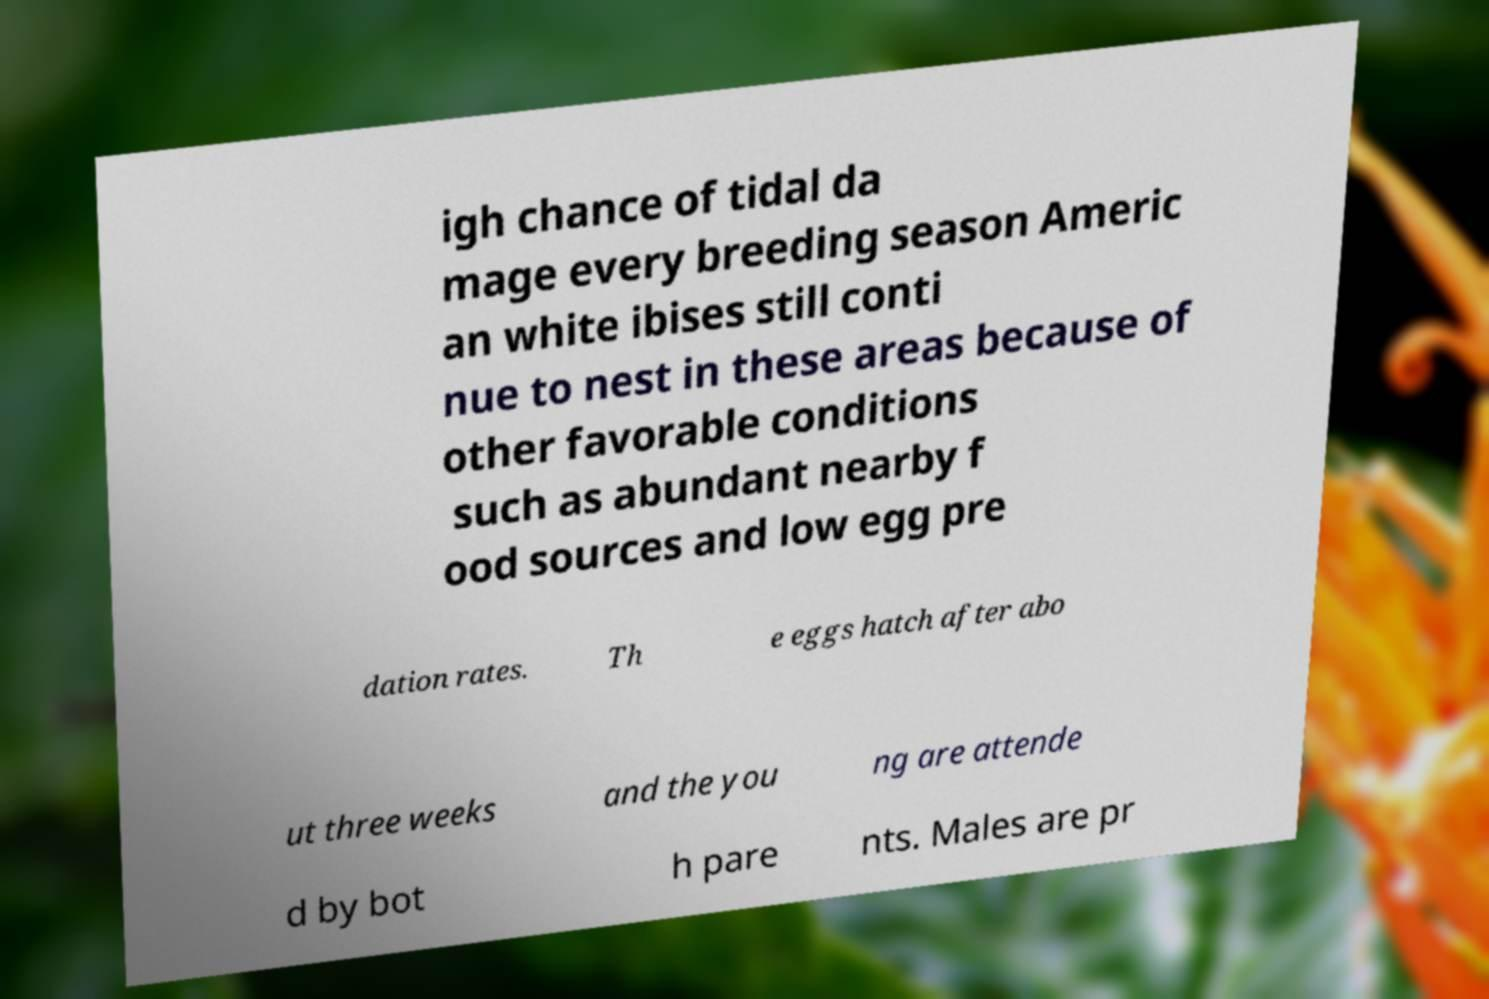I need the written content from this picture converted into text. Can you do that? igh chance of tidal da mage every breeding season Americ an white ibises still conti nue to nest in these areas because of other favorable conditions such as abundant nearby f ood sources and low egg pre dation rates. Th e eggs hatch after abo ut three weeks and the you ng are attende d by bot h pare nts. Males are pr 